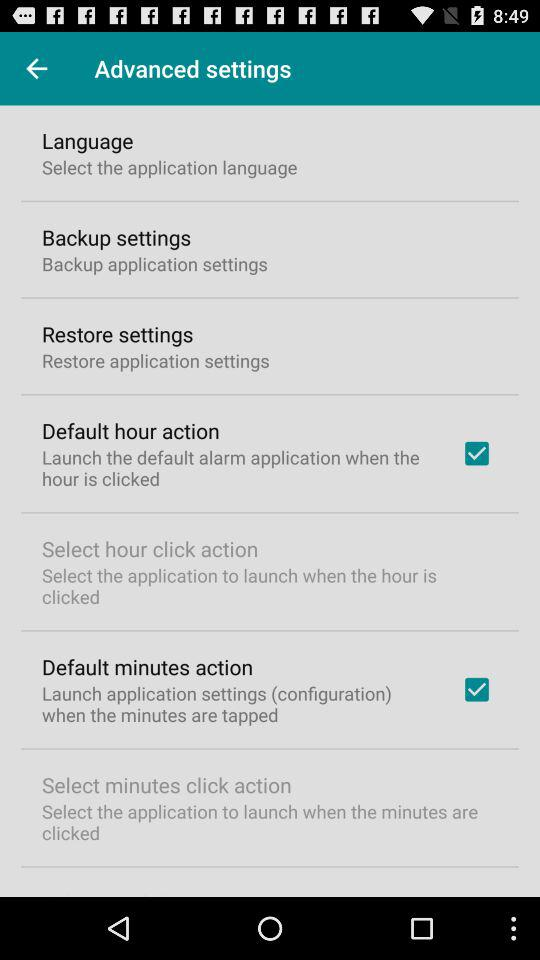What is the status of "Default minutes action"? The status of "Default minutes action" is "on". 